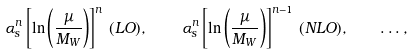<formula> <loc_0><loc_0><loc_500><loc_500>\alpha _ { s } ^ { n } \left [ \ln \left ( \frac { \mu } { M _ { W } } \right ) \right ] ^ { n } \, ( L O ) , \quad \, \alpha _ { s } ^ { n } \left [ \ln \left ( \frac { \mu } { M _ { W } } \right ) \right ] ^ { n - 1 } \, ( N L O ) , \quad \dots ,</formula> 